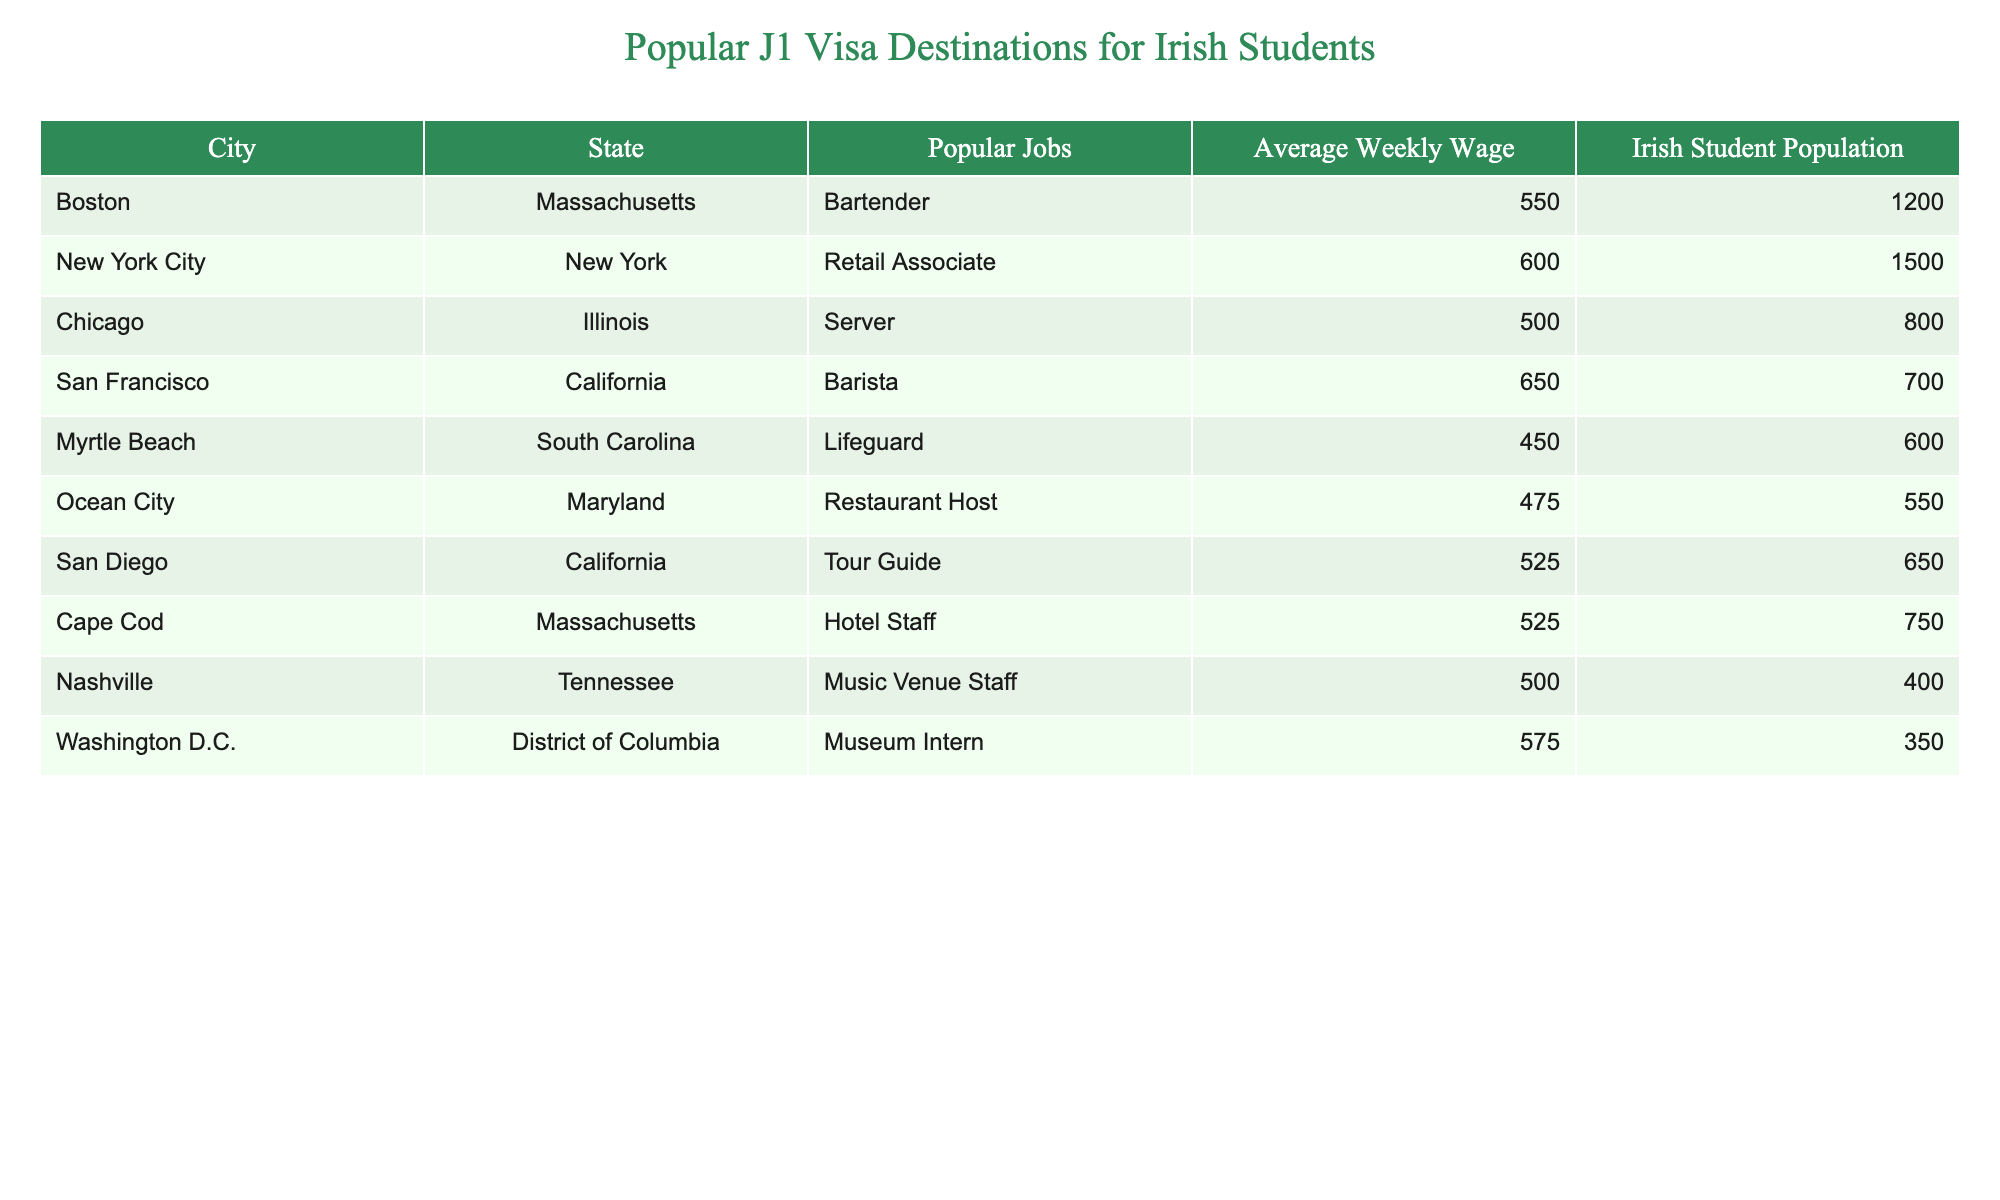What is the city with the highest average weekly wage? By comparing the "Average Weekly Wage" column, I see that San Francisco, California has the highest value at $650.
Answer: San Francisco How many Irish students are in New York City? Referring to the "Irish Student Population" column, New York City has 1500 Irish students listed.
Answer: 1500 Which city has the lowest average weekly wage among the listed destinations? Looking at the "Average Weekly Wage" column, Myrtle Beach, South Carolina has the lowest wage at $450.
Answer: Myrtle Beach What is the total Irish student population for all cities listed? To find this, I sum the values in the "Irish Student Population" column: 1200 + 1500 + 800 + 700 + 600 + 550 + 650 + 750 + 400 + 350 = 7250.
Answer: 7250 How much higher is the average weekly wage in San Francisco compared to Chicago? First, I note the average weekly wage for San Francisco is $650, and for Chicago, it is $500. The difference is $650 - $500 = $150.
Answer: $150 Is there a city listed with an Irish student population over 1000? Yes, by checking the "Irish Student Population" column, Boston (1200) and New York City (1500) both have populations over 1000.
Answer: Yes Which city has the same average weekly wage as Cape Cod? Looking at the "Average Weekly Wage" column, I see Cape Cod and San Diego both have an average weekly wage of $525.
Answer: San Diego What is the average Irish student population across these cities? To find the average, I sum the populations (7250) and divide by the number of cities (10): 7250 / 10 = 725.
Answer: 725 Are there more Irish students in Boston than in Washington D.C.? Boston has 1200 Irish students while Washington D.C. has 350. Since 1200 > 350, the answer is affirmative.
Answer: Yes What percentage of the total Irish student population does San Francisco represent? San Francisco has an Irish student population of 700. The total is 7250. Calculating the percentage: (700 / 7250) * 100 = about 9.66%.
Answer: 9.66% 